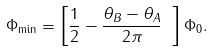<formula> <loc_0><loc_0><loc_500><loc_500>\Phi _ { \min } = \left [ \frac { 1 } { 2 } - \frac { \theta _ { B } - \theta _ { A } } { 2 \pi } \ \right ] \Phi _ { 0 } .</formula> 